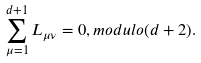Convert formula to latex. <formula><loc_0><loc_0><loc_500><loc_500>\sum _ { \mu = 1 } ^ { d + 1 } L _ { \mu \nu } = 0 , m o d u l o ( d + 2 ) .</formula> 